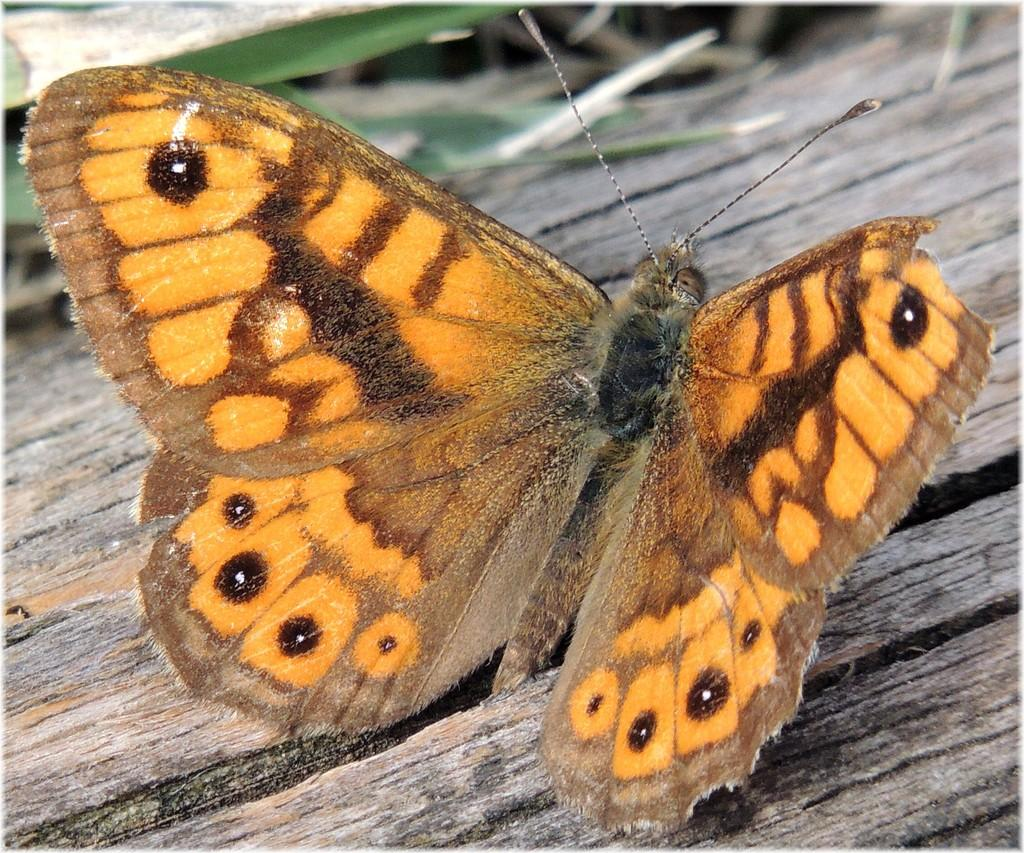What is the main subject of the image? There is a butterfly in the image. What type of surface is the butterfly on? The butterfly is on a wooden surface. What type of rifle is the butterfly holding in the image? There is no rifle present in the image; the butterfly is simply resting on a wooden surface. 